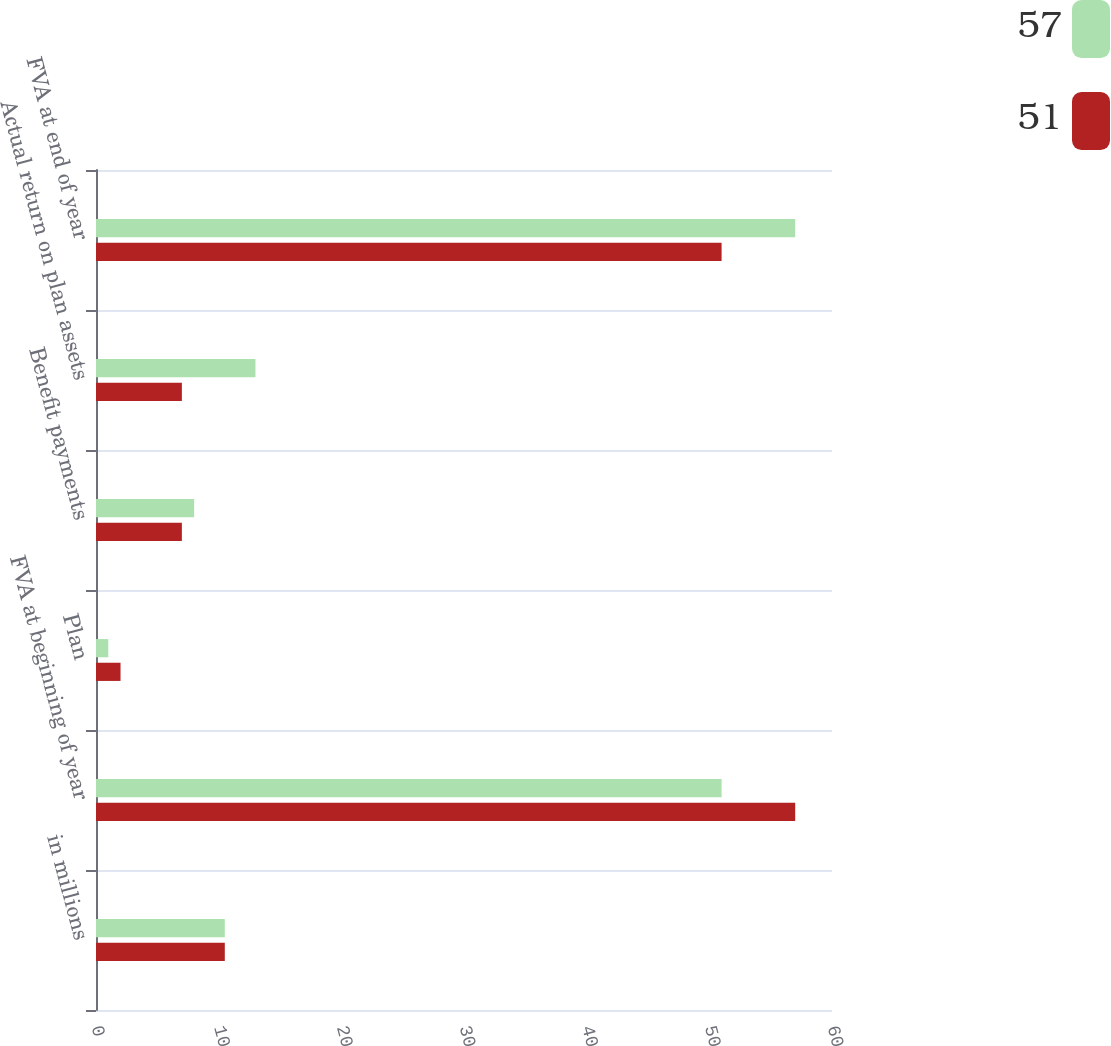<chart> <loc_0><loc_0><loc_500><loc_500><stacked_bar_chart><ecel><fcel>in millions<fcel>FVA at beginning of year<fcel>Plan<fcel>Benefit payments<fcel>Actual return on plan assets<fcel>FVA at end of year<nl><fcel>57<fcel>10.5<fcel>51<fcel>1<fcel>8<fcel>13<fcel>57<nl><fcel>51<fcel>10.5<fcel>57<fcel>2<fcel>7<fcel>7<fcel>51<nl></chart> 